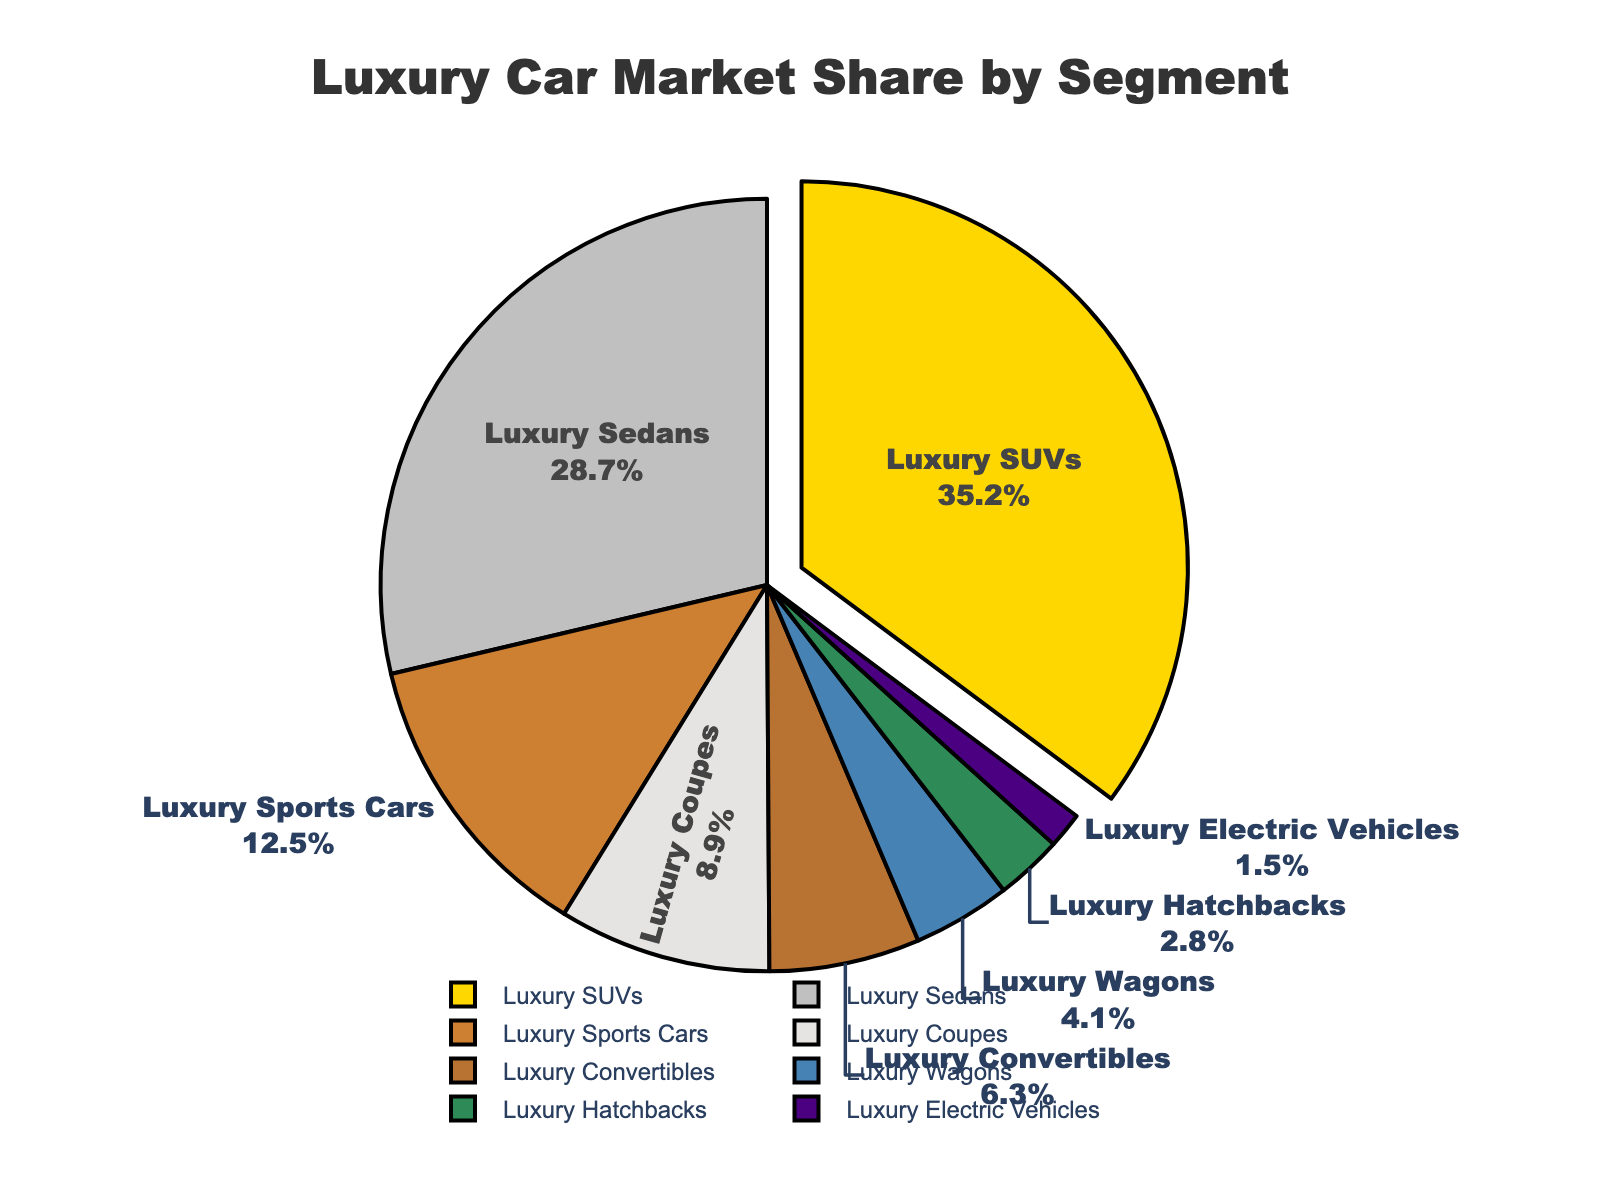What is the market share of Luxury SUVs? The figure shows that the Luxury SUVs segment occupies 35.2% of the market share. This information is directly displayed in the pie chart.
Answer: 35.2% Which segment has the smallest market share? From the pie chart, the Luxury Electric Vehicles segment has the smallest market share at 1.5%. This is the least indicated percentage on the chart.
Answer: Luxury Electric Vehicles What is the combined market share of Luxury Sedans and Luxury Sports Cars? To calculate the combined market share, sum up the shares of Luxury Sedans (28.7%) and Luxury Sports Cars (12.5%): 28.7% + 12.5% = 41.2%.
Answer: 41.2% Which segment’s share is greater, Luxury Convertibles or Luxury Hatchbacks? According to the pie chart, Luxury Convertibles have a market share of 6.3%, which is greater than the 2.8% market share of Luxury Hatchbacks.
Answer: Luxury Convertibles What is the difference in market share between the largest and smallest segments? The largest segment, Luxury SUVs, has a market share of 35.2%, while the smallest segment, Luxury Electric Vehicles, has 1.5%. The difference is 35.2% - 1.5% = 33.7%.
Answer: 33.7% Which segments have a market share between 5% and 10%? The pie chart indicates that Luxury Coupes have an 8.9% share and Luxury Convertibles have a 6.3% share. These are the segments within the range of 5% to 10%.
Answer: Luxury Coupes and Luxury Convertibles How does the market share of Luxury Wagons compare to the market share of Luxury Hatchbacks? Luxury Wagons have a market share of 4.1%, which is greater than the 2.8% market share of Luxury Hatchbacks.
Answer: Luxury Wagons If the market share of Luxury SUVs increased by 5%, what would be the new market share? The current market share of Luxury SUVs is 35.2%. Adding a 5% increase would result in 35.2% + 5% = 40.2%.
Answer: 40.2% What segments form the top three largest market shares? The top three segments by market share are Luxury SUVs (35.2%), Luxury Sedans (28.7%), and Luxury Sports Cars (12.5%), as indicated by the pie chart's proportions.
Answer: Luxury SUVs, Luxury Sedans, and Luxury Sports Cars Which segment is pulled out slightly in the pie chart? In the pie chart, the Luxury SUVs segment is slightly pulled out to emphasize it. This segment is highlighted visually to draw attention.
Answer: Luxury SUVs 